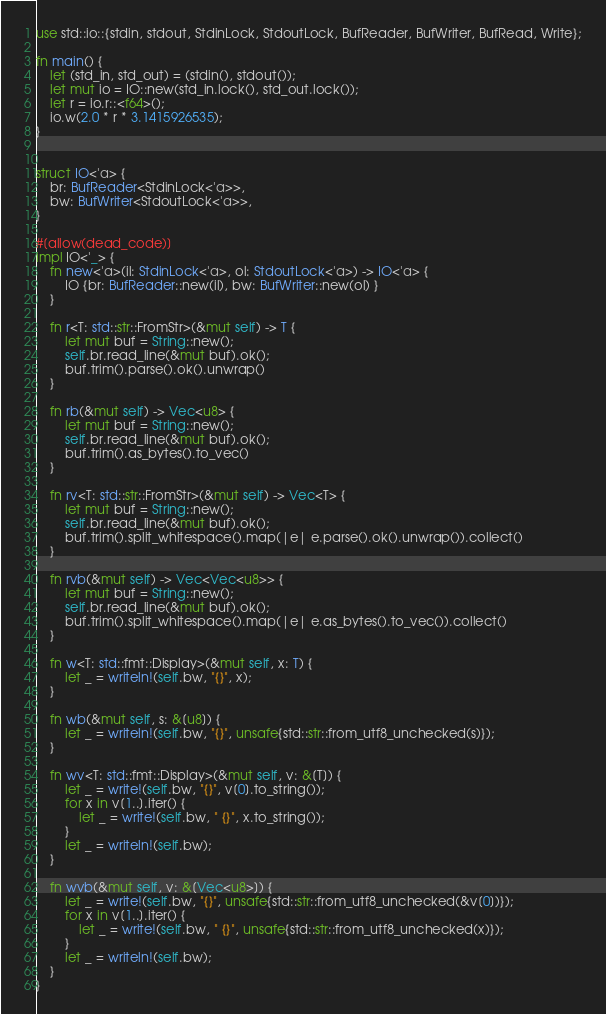Convert code to text. <code><loc_0><loc_0><loc_500><loc_500><_Rust_>use std::io::{stdin, stdout, StdinLock, StdoutLock, BufReader, BufWriter, BufRead, Write};

fn main() {
    let (std_in, std_out) = (stdin(), stdout());
    let mut io = IO::new(std_in.lock(), std_out.lock());
    let r = io.r::<f64>();
    io.w(2.0 * r * 3.1415926535);
}


struct IO<'a> {
    br: BufReader<StdinLock<'a>>,
    bw: BufWriter<StdoutLock<'a>>,
}

#[allow(dead_code)]
impl IO<'_> {
    fn new<'a>(il: StdinLock<'a>, ol: StdoutLock<'a>) -> IO<'a> {
        IO {br: BufReader::new(il), bw: BufWriter::new(ol) }
    }

    fn r<T: std::str::FromStr>(&mut self) -> T {
        let mut buf = String::new();
        self.br.read_line(&mut buf).ok();
        buf.trim().parse().ok().unwrap()
    }

    fn rb(&mut self) -> Vec<u8> {
        let mut buf = String::new();
        self.br.read_line(&mut buf).ok();
        buf.trim().as_bytes().to_vec()
    }

    fn rv<T: std::str::FromStr>(&mut self) -> Vec<T> {
        let mut buf = String::new();
        self.br.read_line(&mut buf).ok();
        buf.trim().split_whitespace().map(|e| e.parse().ok().unwrap()).collect()
    }

    fn rvb(&mut self) -> Vec<Vec<u8>> {
        let mut buf = String::new();
        self.br.read_line(&mut buf).ok();
        buf.trim().split_whitespace().map(|e| e.as_bytes().to_vec()).collect()
    }

    fn w<T: std::fmt::Display>(&mut self, x: T) {
        let _ = writeln!(self.bw, "{}", x);
    }

    fn wb(&mut self, s: &[u8]) {
        let _ = writeln!(self.bw, "{}", unsafe{std::str::from_utf8_unchecked(s)});
    }

    fn wv<T: std::fmt::Display>(&mut self, v: &[T]) {
        let _ = write!(self.bw, "{}", v[0].to_string());
        for x in v[1..].iter() {
            let _ = write!(self.bw, " {}", x.to_string());
        }
        let _ = writeln!(self.bw);
    }

    fn wvb(&mut self, v: &[Vec<u8>]) {
        let _ = write!(self.bw, "{}", unsafe{std::str::from_utf8_unchecked(&v[0])});
        for x in v[1..].iter() {
            let _ = write!(self.bw, " {}", unsafe{std::str::from_utf8_unchecked(x)});
        }
        let _ = writeln!(self.bw);
    }
}
</code> 